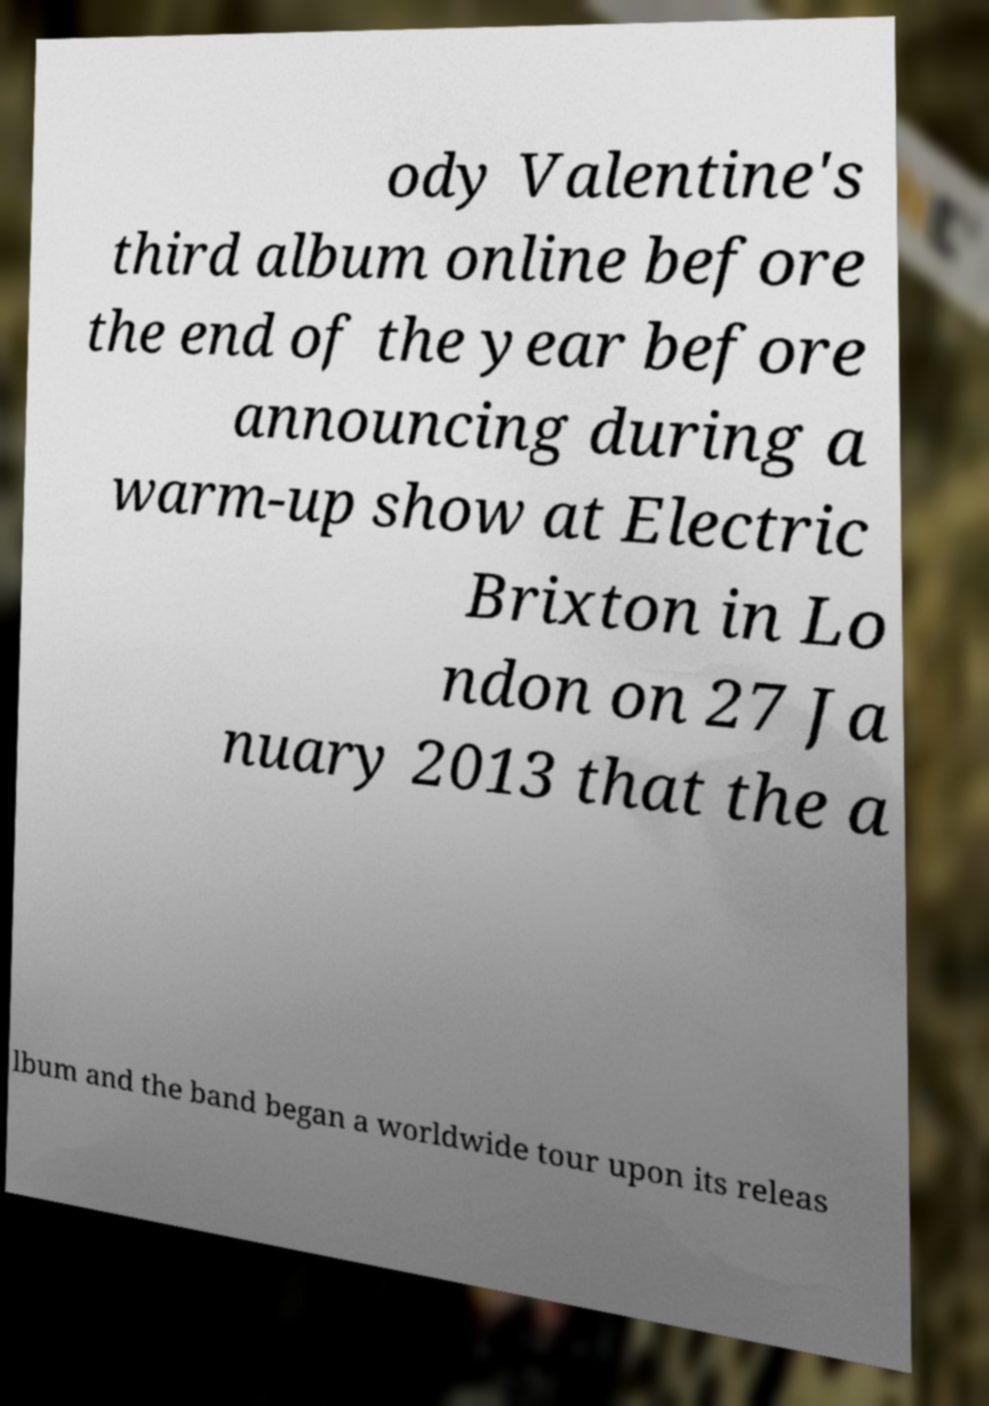I need the written content from this picture converted into text. Can you do that? ody Valentine's third album online before the end of the year before announcing during a warm-up show at Electric Brixton in Lo ndon on 27 Ja nuary 2013 that the a lbum and the band began a worldwide tour upon its releas 